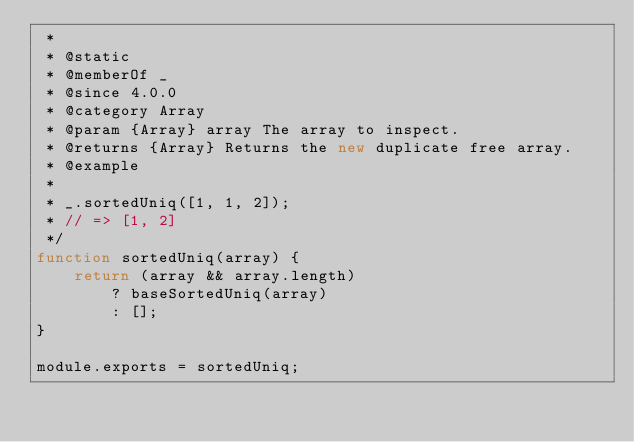Convert code to text. <code><loc_0><loc_0><loc_500><loc_500><_JavaScript_> *
 * @static
 * @memberOf _
 * @since 4.0.0
 * @category Array
 * @param {Array} array The array to inspect.
 * @returns {Array} Returns the new duplicate free array.
 * @example
 *
 * _.sortedUniq([1, 1, 2]);
 * // => [1, 2]
 */
function sortedUniq(array) {
    return (array && array.length)
        ? baseSortedUniq(array)
        : [];
}

module.exports = sortedUniq;
</code> 